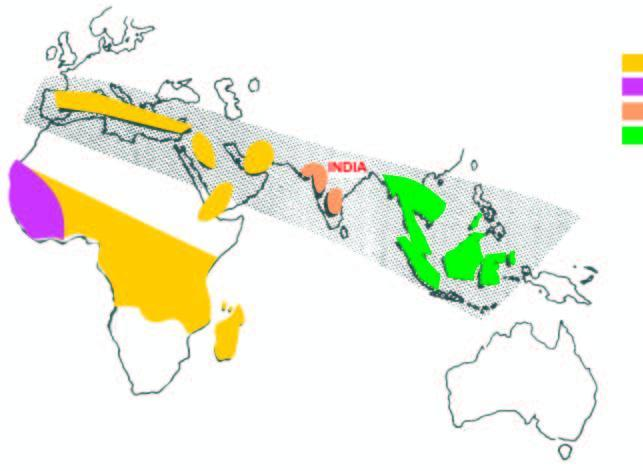re thalassaemia and hbd the haemoglobin disorders common in india?
Answer the question using a single word or phrase. Yes 